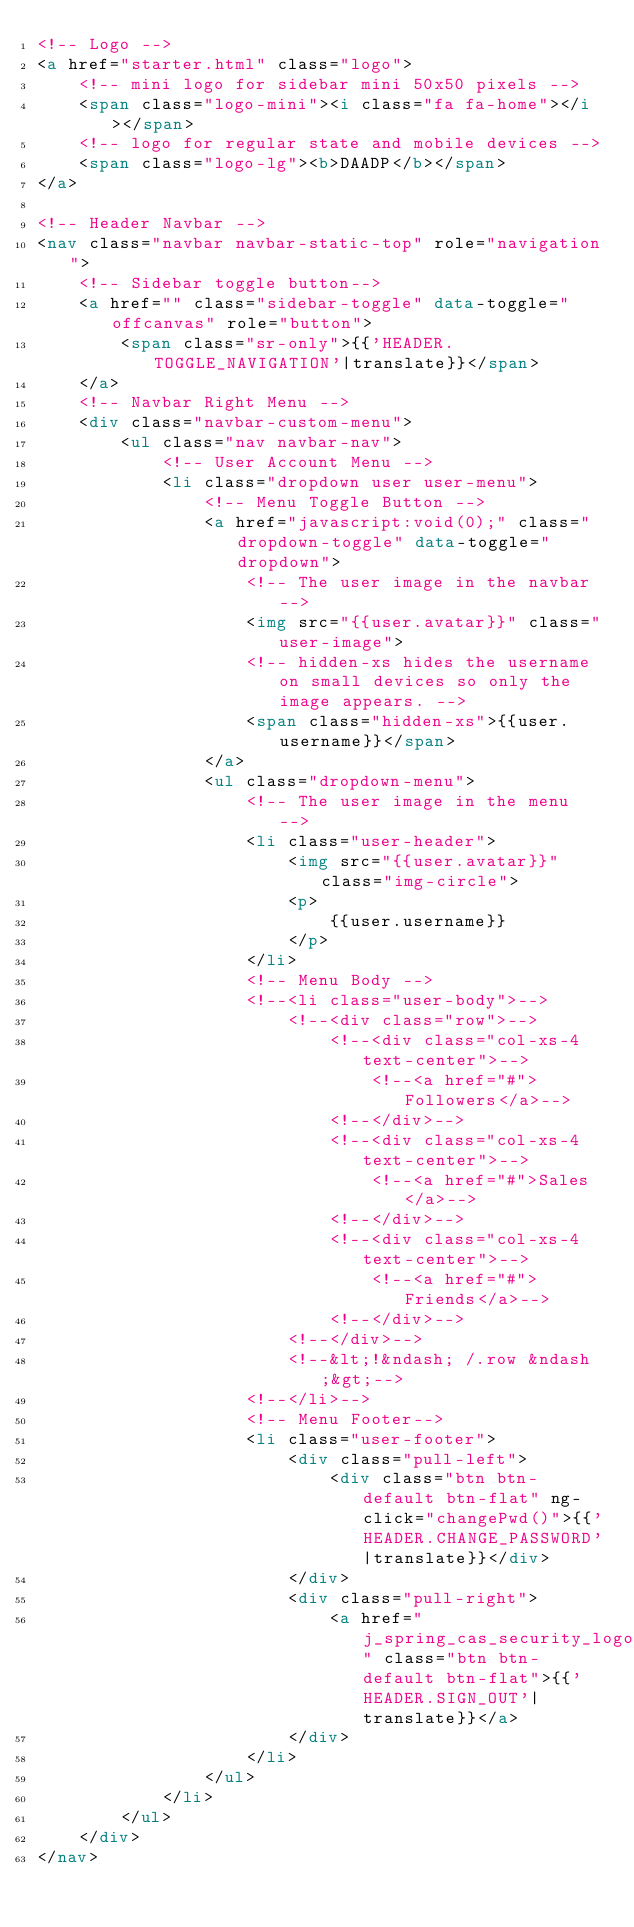Convert code to text. <code><loc_0><loc_0><loc_500><loc_500><_HTML_><!-- Logo -->
<a href="starter.html" class="logo">
    <!-- mini logo for sidebar mini 50x50 pixels -->
    <span class="logo-mini"><i class="fa fa-home"></i></span>
    <!-- logo for regular state and mobile devices -->
    <span class="logo-lg"><b>DAADP</b></span>
</a>

<!-- Header Navbar -->
<nav class="navbar navbar-static-top" role="navigation">
    <!-- Sidebar toggle button-->
    <a href="" class="sidebar-toggle" data-toggle="offcanvas" role="button">
        <span class="sr-only">{{'HEADER.TOGGLE_NAVIGATION'|translate}}</span>
    </a>
    <!-- Navbar Right Menu -->
    <div class="navbar-custom-menu">
        <ul class="nav navbar-nav">
            <!-- User Account Menu -->
            <li class="dropdown user user-menu">
                <!-- Menu Toggle Button -->
                <a href="javascript:void(0);" class="dropdown-toggle" data-toggle="dropdown">
                    <!-- The user image in the navbar-->
                    <img src="{{user.avatar}}" class="user-image">
                    <!-- hidden-xs hides the username on small devices so only the image appears. -->
                    <span class="hidden-xs">{{user.username}}</span>
                </a>
                <ul class="dropdown-menu">
                    <!-- The user image in the menu -->
                    <li class="user-header">
                        <img src="{{user.avatar}}" class="img-circle">
                        <p>
                            {{user.username}}
                        </p>
                    </li>
                    <!-- Menu Body -->
                    <!--<li class="user-body">-->
                        <!--<div class="row">-->
                            <!--<div class="col-xs-4 text-center">-->
                                <!--<a href="#">Followers</a>-->
                            <!--</div>-->
                            <!--<div class="col-xs-4 text-center">-->
                                <!--<a href="#">Sales</a>-->
                            <!--</div>-->
                            <!--<div class="col-xs-4 text-center">-->
                                <!--<a href="#">Friends</a>-->
                            <!--</div>-->
                        <!--</div>-->
                        <!--&lt;!&ndash; /.row &ndash;&gt;-->
                    <!--</li>-->
                    <!-- Menu Footer-->
                    <li class="user-footer">
                        <div class="pull-left">
                            <div class="btn btn-default btn-flat" ng-click="changePwd()">{{'HEADER.CHANGE_PASSWORD'|translate}}</div>
                        </div>
                        <div class="pull-right">
                            <a href="j_spring_cas_security_logout" class="btn btn-default btn-flat">{{'HEADER.SIGN_OUT'|translate}}</a>
                        </div>
                    </li>
                </ul>
            </li>
        </ul>
    </div>
</nav></code> 